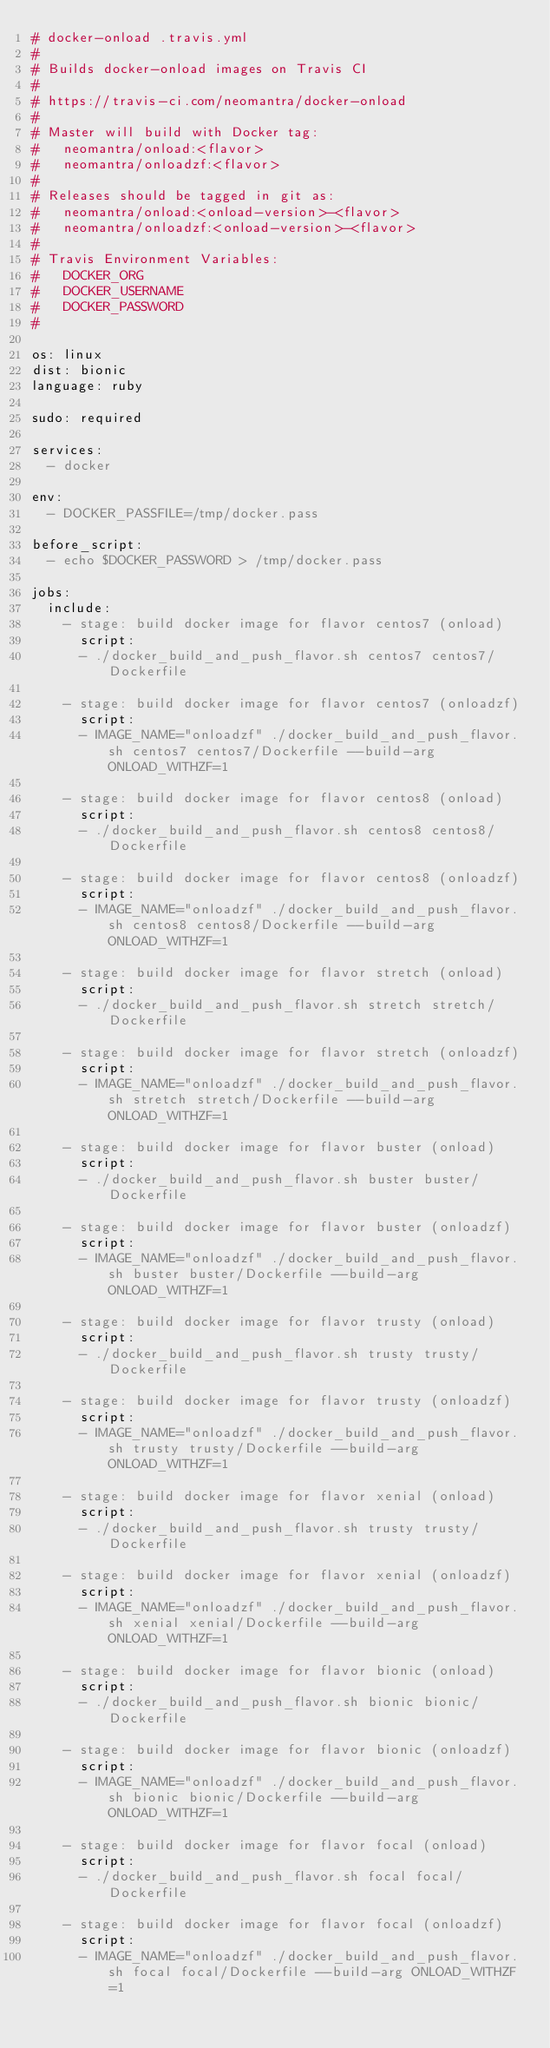Convert code to text. <code><loc_0><loc_0><loc_500><loc_500><_YAML_># docker-onload .travis.yml
#
# Builds docker-onload images on Travis CI
#
# https://travis-ci.com/neomantra/docker-onload
#
# Master will build with Docker tag:
#   neomantra/onload:<flavor>
#   neomantra/onloadzf:<flavor>
#
# Releases should be tagged in git as:
#   neomantra/onload:<onload-version>-<flavor>
#   neomantra/onloadzf:<onload-version>-<flavor>
#
# Travis Environment Variables:
#   DOCKER_ORG
#   DOCKER_USERNAME
#   DOCKER_PASSWORD
#

os: linux
dist: bionic
language: ruby

sudo: required

services:
  - docker

env:
  - DOCKER_PASSFILE=/tmp/docker.pass

before_script:
  - echo $DOCKER_PASSWORD > /tmp/docker.pass

jobs:
  include:
    - stage: build docker image for flavor centos7 (onload)
      script:
      - ./docker_build_and_push_flavor.sh centos7 centos7/Dockerfile

    - stage: build docker image for flavor centos7 (onloadzf)
      script:
      - IMAGE_NAME="onloadzf" ./docker_build_and_push_flavor.sh centos7 centos7/Dockerfile --build-arg ONLOAD_WITHZF=1

    - stage: build docker image for flavor centos8 (onload)
      script:
      - ./docker_build_and_push_flavor.sh centos8 centos8/Dockerfile

    - stage: build docker image for flavor centos8 (onloadzf)
      script:
      - IMAGE_NAME="onloadzf" ./docker_build_and_push_flavor.sh centos8 centos8/Dockerfile --build-arg ONLOAD_WITHZF=1

    - stage: build docker image for flavor stretch (onload)
      script:
      - ./docker_build_and_push_flavor.sh stretch stretch/Dockerfile

    - stage: build docker image for flavor stretch (onloadzf)
      script:
      - IMAGE_NAME="onloadzf" ./docker_build_and_push_flavor.sh stretch stretch/Dockerfile --build-arg ONLOAD_WITHZF=1

    - stage: build docker image for flavor buster (onload)
      script:
      - ./docker_build_and_push_flavor.sh buster buster/Dockerfile

    - stage: build docker image for flavor buster (onloadzf)
      script:
      - IMAGE_NAME="onloadzf" ./docker_build_and_push_flavor.sh buster buster/Dockerfile --build-arg ONLOAD_WITHZF=1

    - stage: build docker image for flavor trusty (onload)
      script:
      - ./docker_build_and_push_flavor.sh trusty trusty/Dockerfile

    - stage: build docker image for flavor trusty (onloadzf)
      script:
      - IMAGE_NAME="onloadzf" ./docker_build_and_push_flavor.sh trusty trusty/Dockerfile --build-arg ONLOAD_WITHZF=1

    - stage: build docker image for flavor xenial (onload)
      script:
      - ./docker_build_and_push_flavor.sh trusty trusty/Dockerfile

    - stage: build docker image for flavor xenial (onloadzf)
      script:
      - IMAGE_NAME="onloadzf" ./docker_build_and_push_flavor.sh xenial xenial/Dockerfile --build-arg ONLOAD_WITHZF=1

    - stage: build docker image for flavor bionic (onload)
      script:
      - ./docker_build_and_push_flavor.sh bionic bionic/Dockerfile

    - stage: build docker image for flavor bionic (onloadzf)
      script:
      - IMAGE_NAME="onloadzf" ./docker_build_and_push_flavor.sh bionic bionic/Dockerfile --build-arg ONLOAD_WITHZF=1

    - stage: build docker image for flavor focal (onload)
      script:
      - ./docker_build_and_push_flavor.sh focal focal/Dockerfile

    - stage: build docker image for flavor focal (onloadzf)
      script:
      - IMAGE_NAME="onloadzf" ./docker_build_and_push_flavor.sh focal focal/Dockerfile --build-arg ONLOAD_WITHZF=1
</code> 